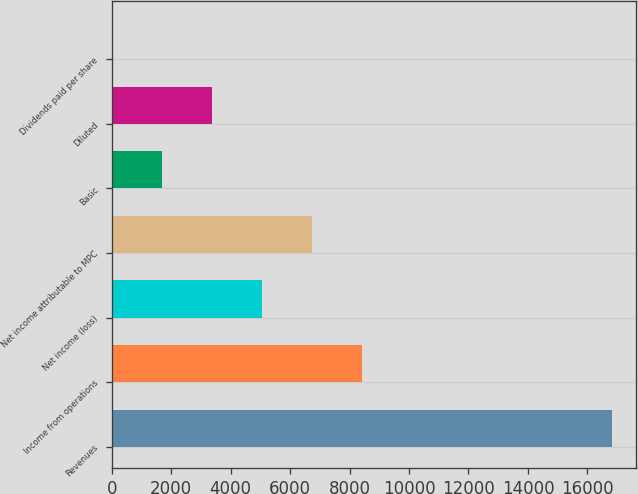<chart> <loc_0><loc_0><loc_500><loc_500><bar_chart><fcel>Revenues<fcel>Income from operations<fcel>Net income (loss)<fcel>Net income attributable to MPC<fcel>Basic<fcel>Diluted<fcel>Dividends paid per share<nl><fcel>16811<fcel>8405.67<fcel>5043.53<fcel>6724.6<fcel>1681.39<fcel>3362.46<fcel>0.32<nl></chart> 